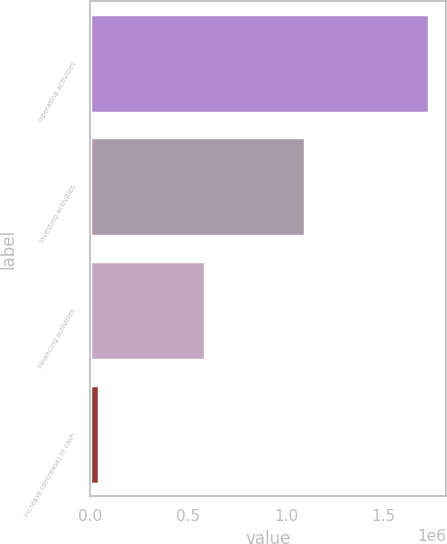Convert chart to OTSL. <chart><loc_0><loc_0><loc_500><loc_500><bar_chart><fcel>Operating activities<fcel>Investing activities<fcel>Financing activities<fcel>Increase (decrease) in cash<nl><fcel>1.73031e+06<fcel>1.09834e+06<fcel>588880<fcel>43087<nl></chart> 